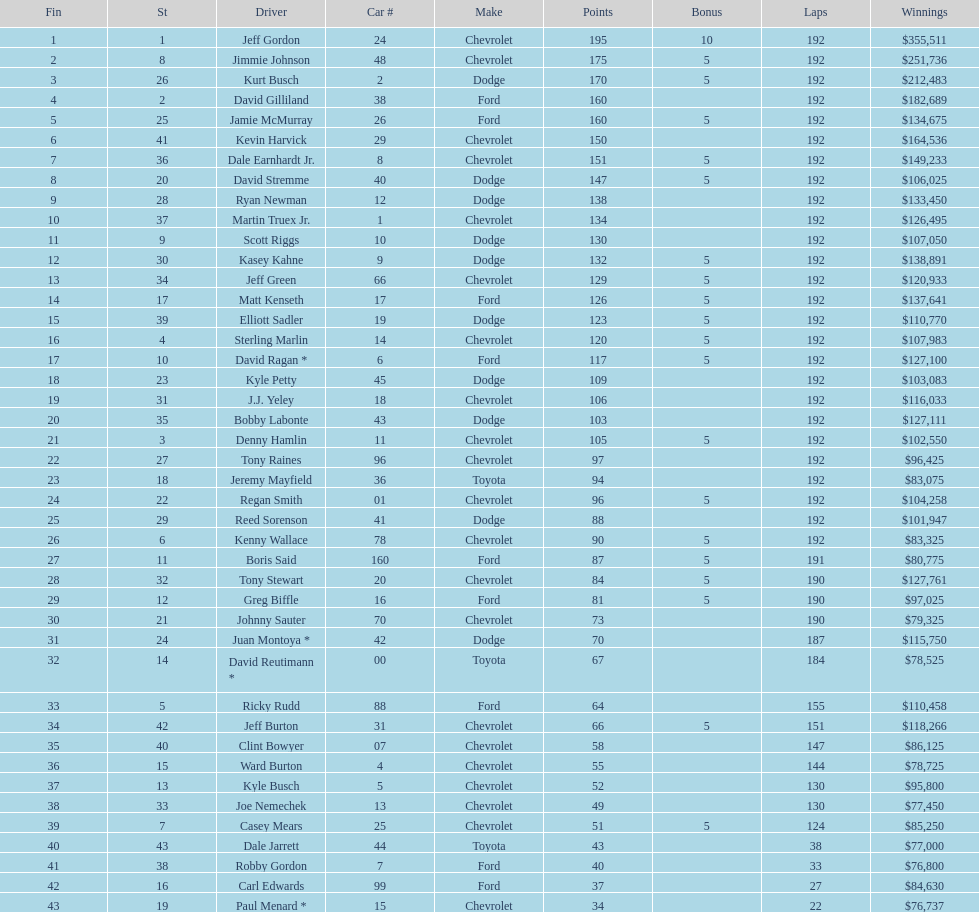Which driver received the smallest amount of earnings? Paul Menard *. 